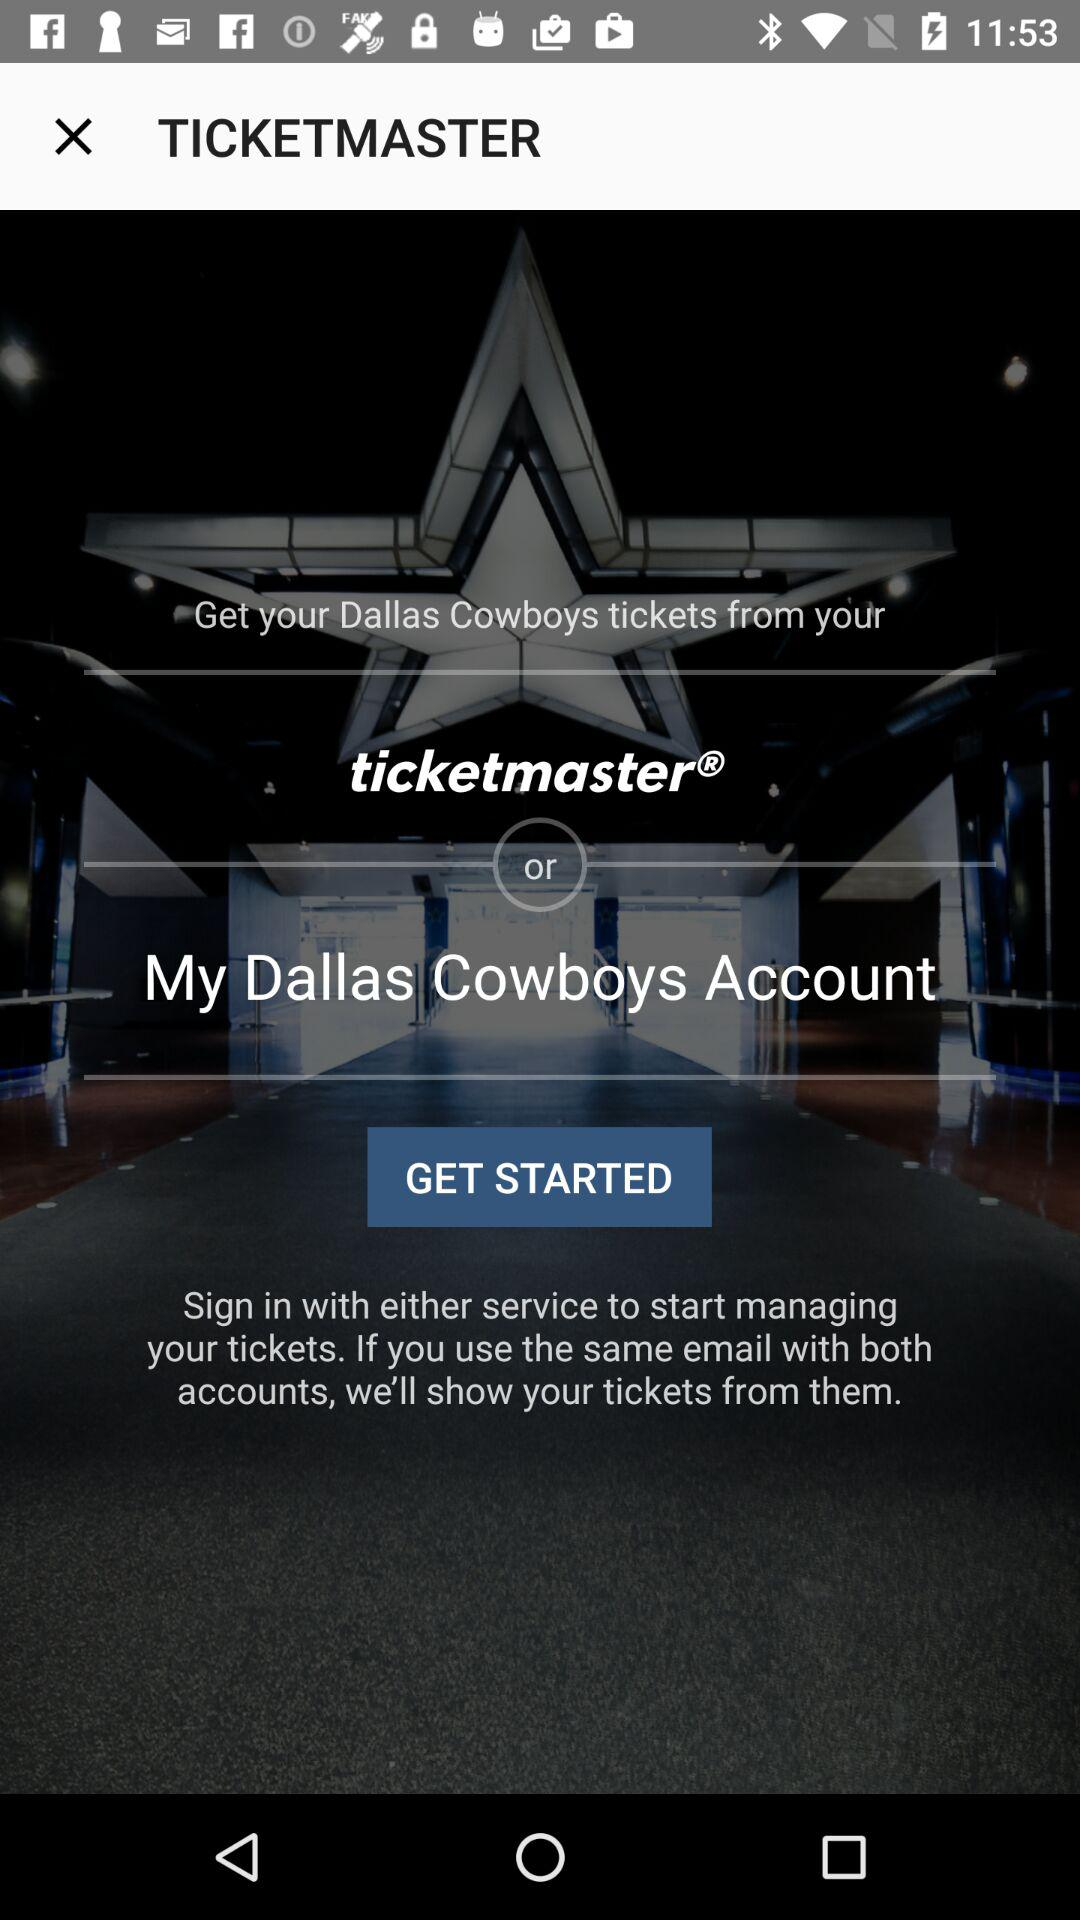How many login options are there?
Answer the question using a single word or phrase. 2 